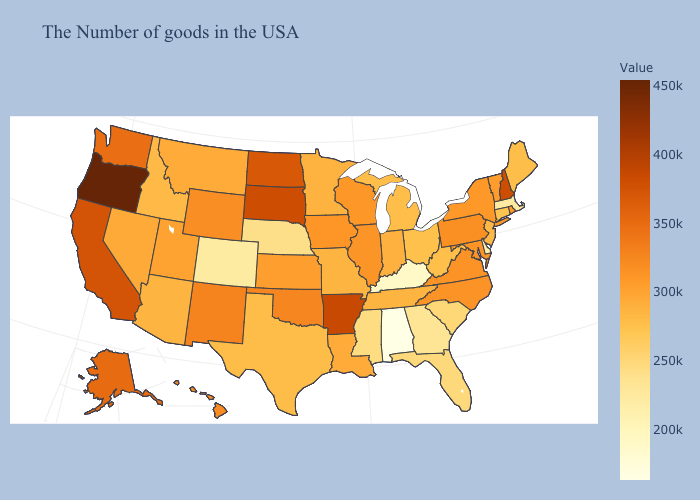Does Oregon have the highest value in the USA?
Be succinct. Yes. Does Iowa have the highest value in the MidWest?
Answer briefly. No. Among the states that border North Dakota , does Minnesota have the lowest value?
Short answer required. Yes. Among the states that border Vermont , which have the lowest value?
Short answer required. Massachusetts. Among the states that border Georgia , which have the lowest value?
Be succinct. Alabama. 